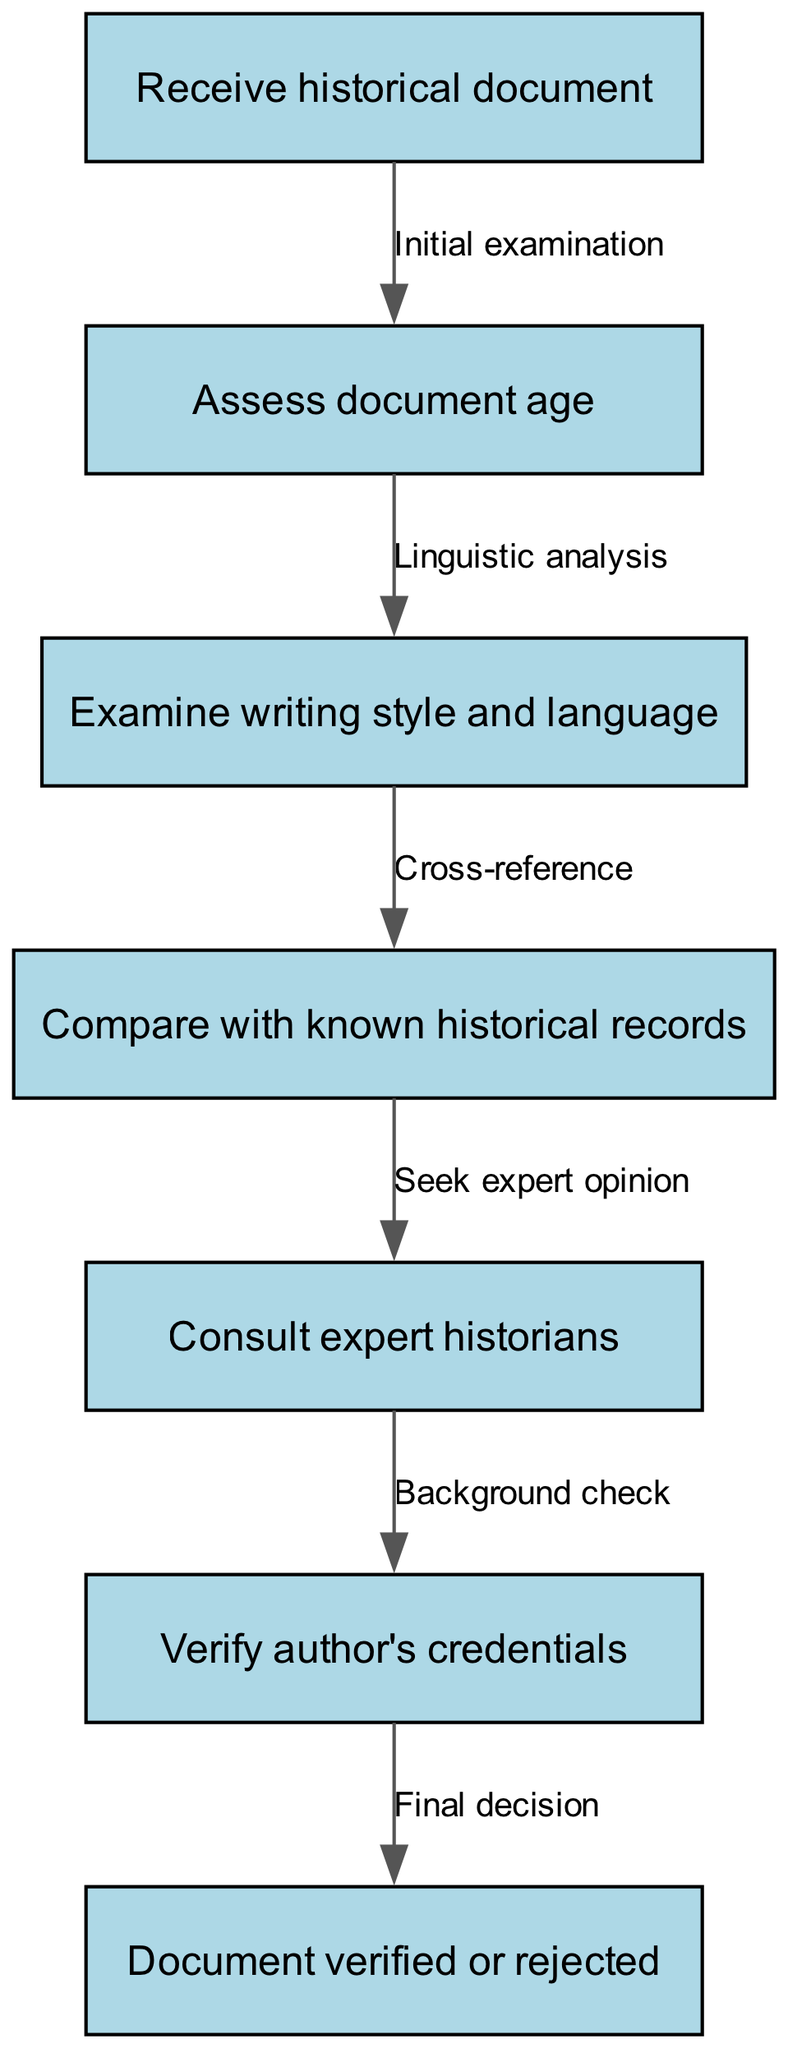What is the first step in the document verification process? The first step according to the diagram is "Receive historical document." This is indicated as the starting node in the flowchart.
Answer: Receive historical document How many nodes are there in the diagram? The diagram contains a total of seven nodes, each representing a distinct step in the verification process.
Answer: 7 What follows after assessing the document age? After assessing the document age, the next step is to "Examine writing style and language," as indicated by the directed edge connecting these two nodes.
Answer: Examine writing style and language What is the final outcome indicated in the diagram? The final outcome in the process is "Document verified or rejected," which is the conclusion of the verification process shown in the last node.
Answer: Document verified or rejected Which step involves seeking help from experts? The step that involves seeking help from experts is "Consult expert historians," as shown in the flow of the diagram following the comparison with historical records.
Answer: Consult expert historians How does the process flow from examining writing style to verifying credentials? After "Examine writing style and language," the process moves to "Compare with known historical records," then to "Seek expert opinion," followed by "Verify author's credentials." This shows a sequential progression in the verification process.
Answer: Through comparison and expert consultation What type of analysis is performed after document age assessment? The type of analysis performed after document age assessment is "Linguistic analysis," which pertains to the examination of style and language next in the process.
Answer: Linguistic analysis 